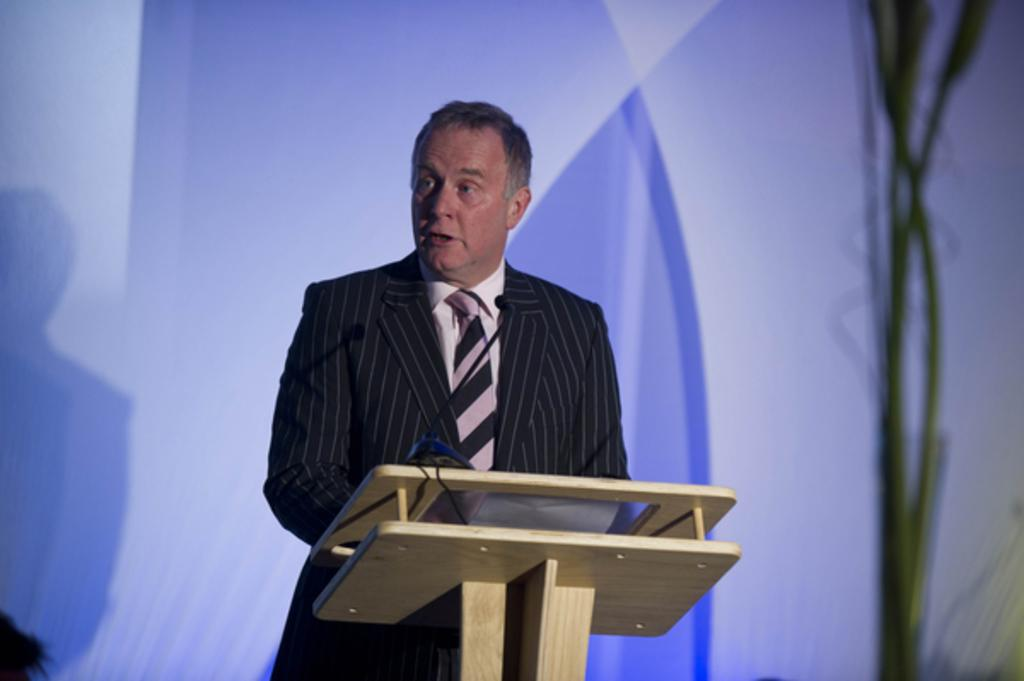What is the man in the image wearing? The man is wearing a suit, a shirt, and a tie. What can be seen on the podium in the image? There is a microphone on the podium. What is the color of the background in the image? The background has a light bluish color. What is the man's tendency to rub the wooden podium in the image? There is no indication in the image of the man rubbing the wooden podium, so it cannot be determined from the picture. 